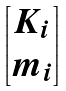<formula> <loc_0><loc_0><loc_500><loc_500>\begin{bmatrix} { K _ { i } } \\ { m _ { i } } \end{bmatrix}</formula> 